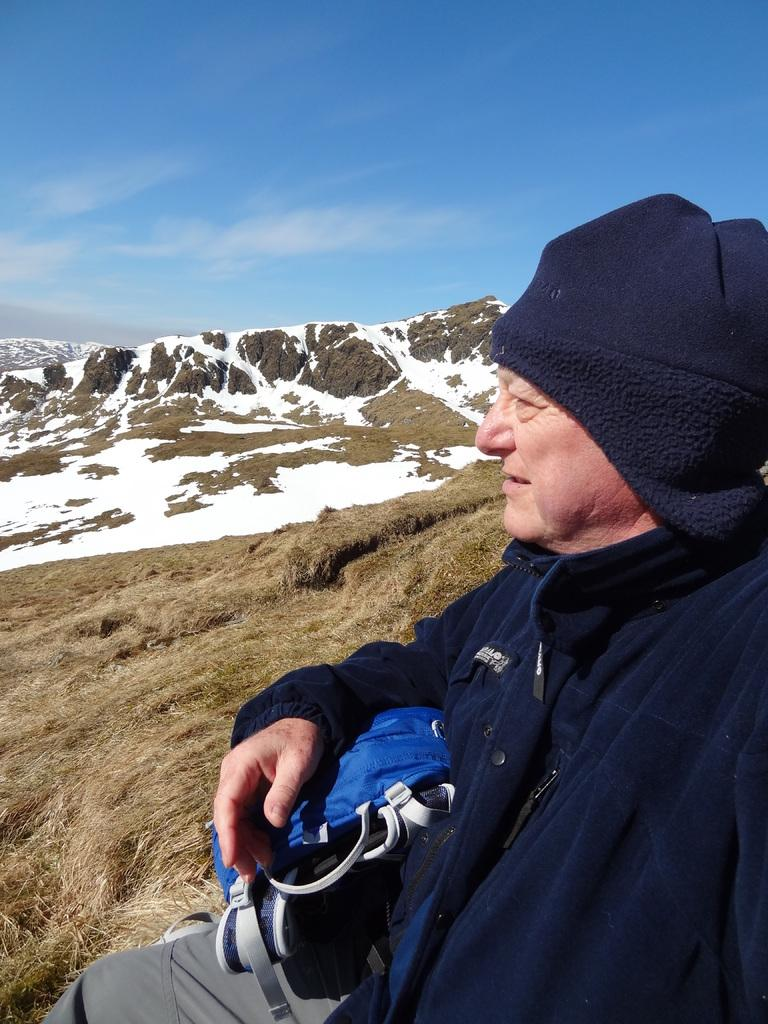What type of natural formation can be seen in the image? There are mountains in the image. What is on the ground in the image? There is grass on the ground in the image. What is covering the mountains in the image? There is snow on the mountains in the image. What is the man in the image doing? The man is sitting and holding an object in the image. What can be seen at the top of the image? The sky is visible at the top of the image. What type of pin is the father wearing on his shirt in the image? There is no father or pin present in the image. How does the man in the image express his happiness? The image does not show the man's facial expression, so it cannot be determined if he is smiling or expressing happiness. 